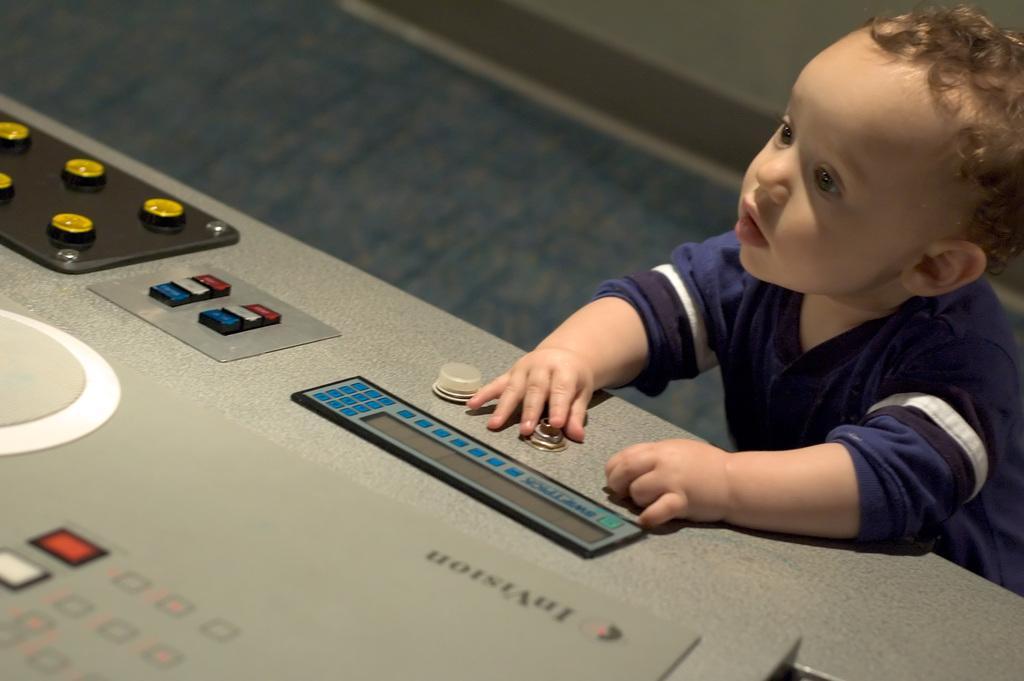Could you give a brief overview of what you see in this image? In this picture there is a boy standing and holding the nob. There are knobs and there are buttons on the device. At the bottom there is a floor. 